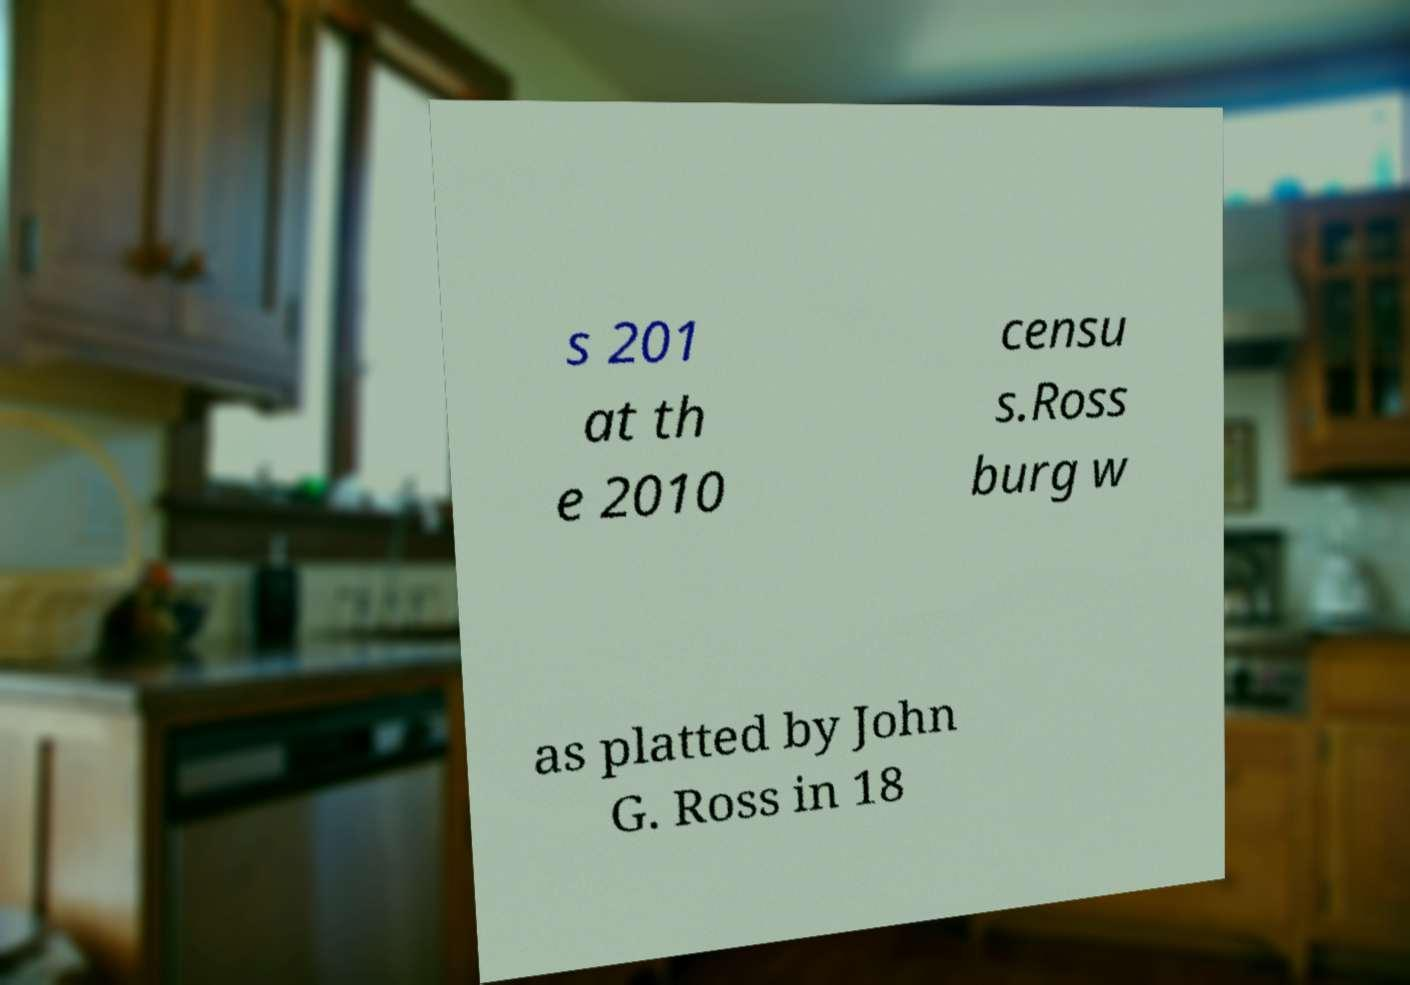Could you assist in decoding the text presented in this image and type it out clearly? s 201 at th e 2010 censu s.Ross burg w as platted by John G. Ross in 18 